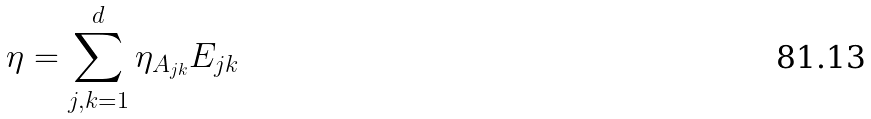Convert formula to latex. <formula><loc_0><loc_0><loc_500><loc_500>\eta = \sum _ { j , k = 1 } ^ { d } \eta _ { A _ { j k } } E _ { j k }</formula> 